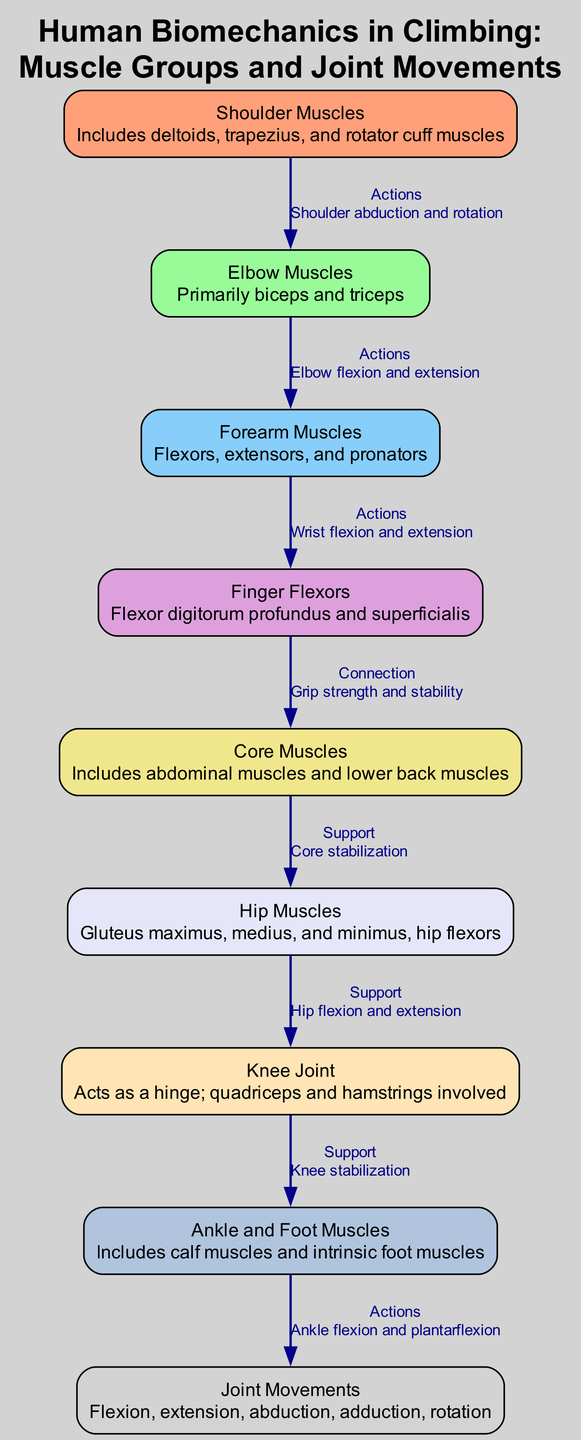What muscles are included in the shoulder group? The diagram identifies the "Shoulder Muscles" node, which describes that it includes deltoids, trapezius, and rotator cuff muscles.
Answer: deltoids, trapezius, and rotator cuff muscles How many muscle groups are listed in the diagram? By counting the nodes representing muscle groups, we find there are nine distinct muscle groups and movements listed.
Answer: Nine What joint movement is associated with the knee joint? Looking at the "Knee Joint" node, it specifies that it acts as a hinge and involves both quadriceps and hamstrings, indicating the primary movement is hinge action.
Answer: Hinge Which muscle group is connected to grip strength? The edge from "Finger Flexors" to "Core Muscles" indicates that grip strength and stability are connected specifically through the finger flexors.
Answer: Finger Flexors What action is associated with ankle and foot muscles? The diagram notes that the "Ankle and Foot Muscles" involve actions of ankle flexion and plantarflexion.
Answer: Flexion and plantarflexion What support does the core provide in climbing? The relationship shown between "Core Muscles" and "Hip Muscles" indicates that core muscles provide stabilization essential for climbing.
Answer: Stabilization Which two muscle groups are directly connected through elbow actions? The edge connecting "Elbow Muscles" to "Forearm Muscles" describes their connection through actions of elbow flexion and extension.
Answer: Elbow and Forearm Muscles Are the shoulder muscles involved in actions related to the elbow? The diagram indicates that shoulder muscles relate to elbow muscles through actions such as shoulder abduction and rotation, thus they are involved.
Answer: Yes What type of joint movement does the diagram list that involves the hip muscles? The connection between "Hip Muscles" and "Knee Joint" indicates the hip muscles are involved in hip flexion and extension, describing a type of joint movement.
Answer: Flexion and extension 